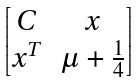<formula> <loc_0><loc_0><loc_500><loc_500>\begin{bmatrix} C & x \\ x ^ { T } & \mu + \frac { 1 } { 4 } \end{bmatrix}</formula> 